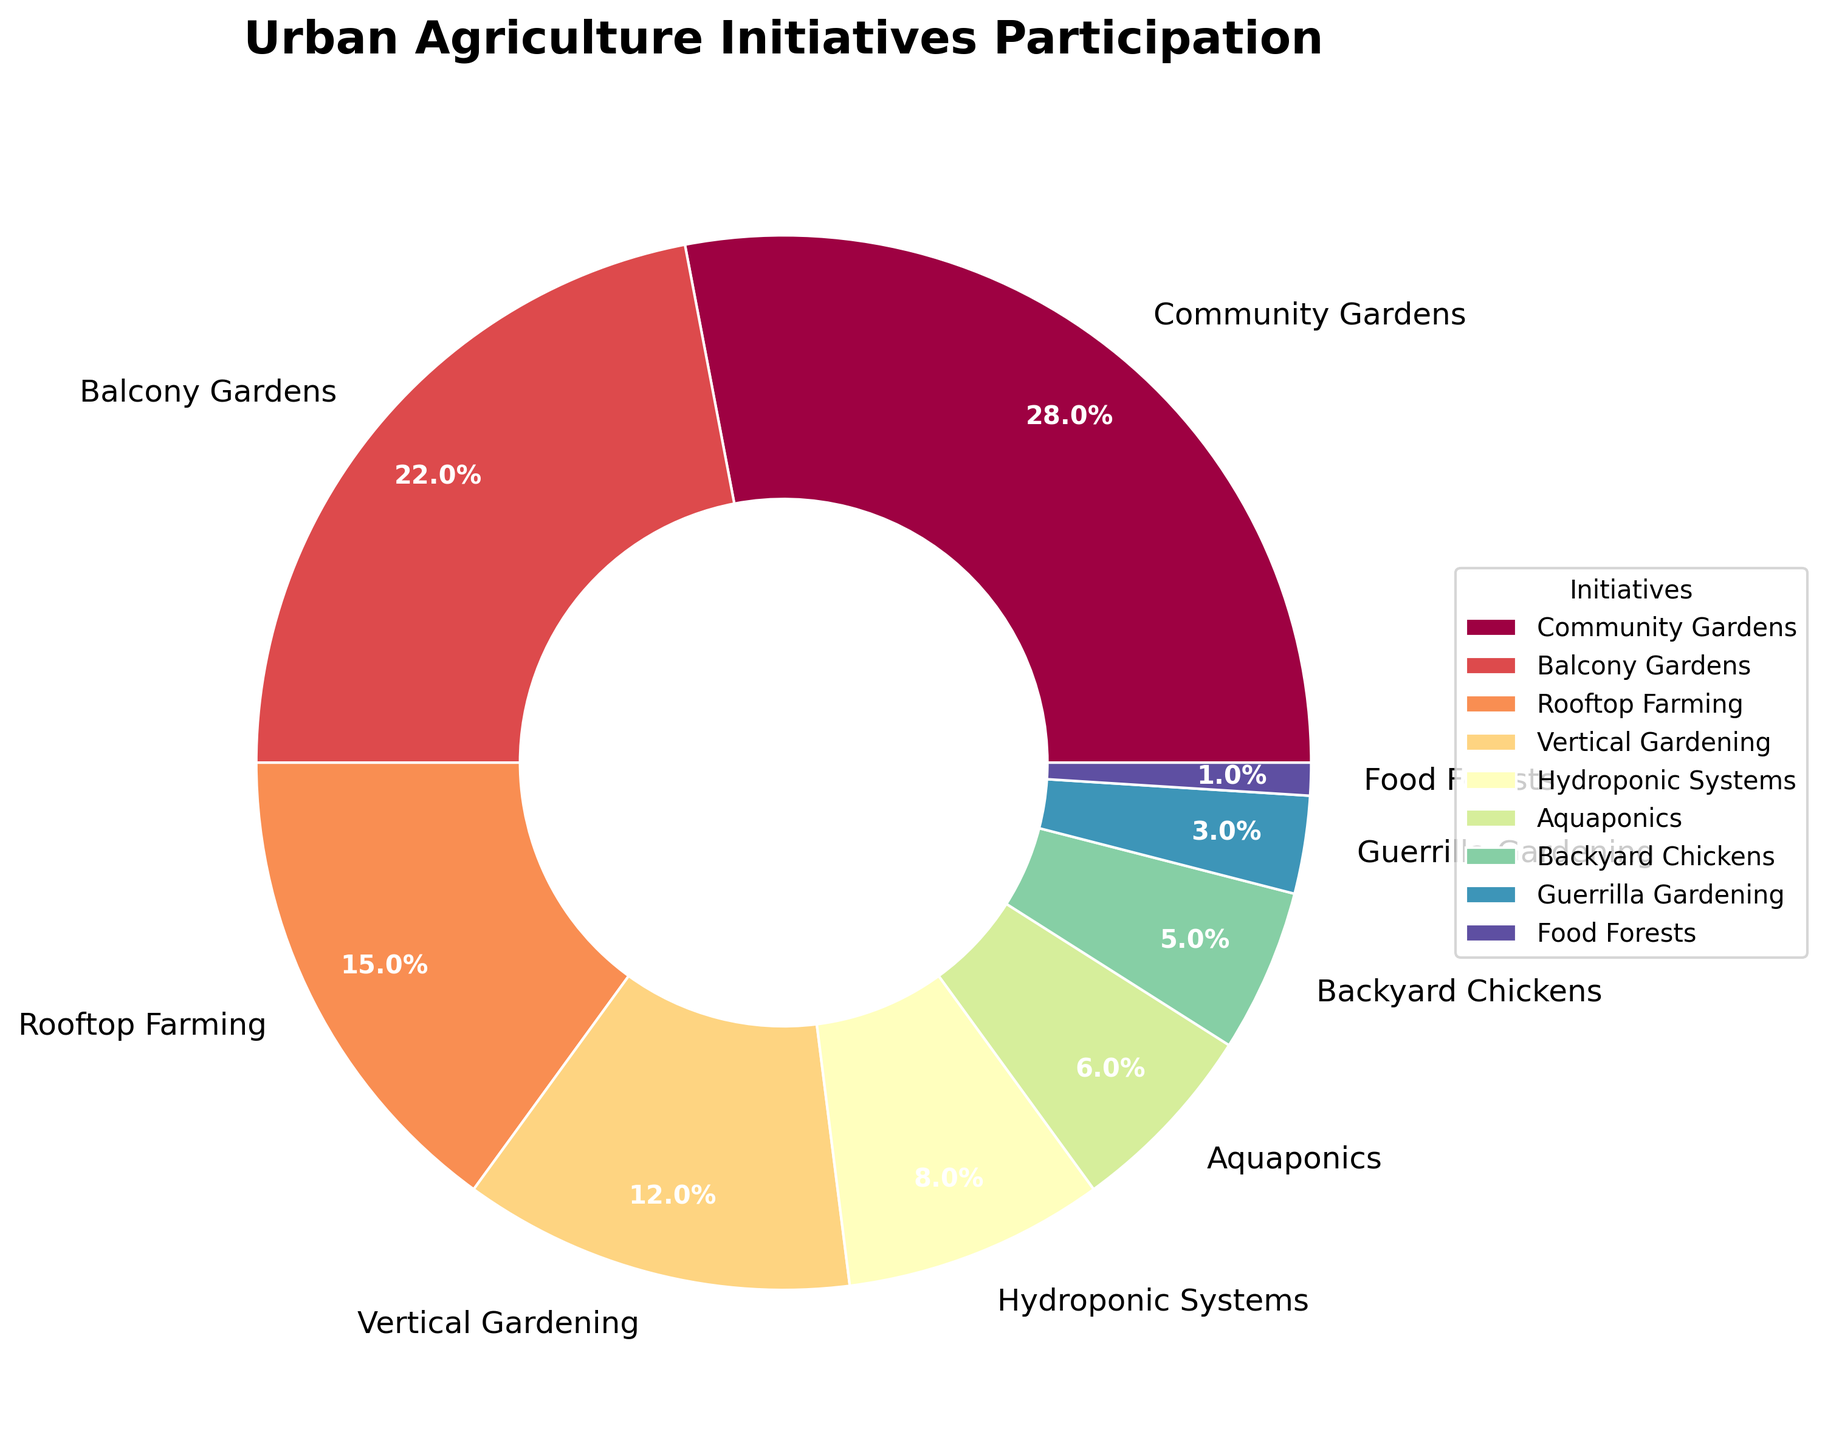What is the total percentage of households participating in Community Gardens and Balcony Gardens combined? To find the total percentage of households participating in Community Gardens and Balcony Gardens, simply add the percentage values for these two initiatives: 28% (Community Gardens) + 22% (Balcony Gardens) = 50%.
Answer: 50% What percentage of households participate in initiatives involving food production (Backyard Chickens and Food Forests) compared to hydroponic systems? Add the percentages of households involved in Backyard Chickens and Food Forests: 5% + 1% = 6%. Compare this sum to Hydroponic Systems: 6% (Backyard Chickens and Food Forests) vs. 8% (Hydroponic Systems).
Answer: 6% vs. 8% Which initiative has more participation: Rooftop Farming or Vertical Gardening? Compare the percentages of Rooftop Farming and Vertical Gardening. Rooftop Farming has 15% and Vertical Gardening has 12%. Therefore, Rooftop Farming has more participation.
Answer: Rooftop Farming What is the combined percentage of households involved in Hydroponic Systems, Aquaponics, and Guerrilla Gardening? Add the percentages of households involved in Hydroponic Systems (8%), Aquaponics (6%), and Guerrilla Gardening (3%): 8% + 6% + 3% = 17%.
Answer: 17% What is the smallest category and its corresponding percentage? Look at the pie chart to identify the smallest section. The smallest category is Food Forests with a percentage of 1%.
Answer: Food Forests, 1% How does the participation in Balcony Gardens compare to Rooftop Farming? Compare the percentages: Balcony Gardens has 22% and Rooftop Farming has 15%. Thus, Balcony Gardens has higher participation.
Answer: Balcony Gardens Which three initiatives have the largest participation and what are their combined percentages? Identify the three largest sections of the pie chart: Community Gardens (28%), Balcony Gardens (22%), and Rooftop Farming (15%). Add their percentages: 28% + 22% + 15% = 65%.
Answer: Community Gardens, Balcony Gardens, Rooftop Farming, 65% Is the participation in Vertical Gardening greater than the combined participation of Aquaponics and Guerrilla Gardening? Compare the percentages: Vertical Gardening has 12%, while the combined participation for Aquaponics (6%) and Guerrilla Gardening (3%) is 6% + 3% = 9%. Vertical Gardening has greater participation.
Answer: Yes, Vertical Gardening is greater What is the color distribution's significance in differentiating the initiatives? The pie chart uses a range of colors from a spectral colormap to visually distinguish between different initiatives. Each sector is a different color, making it easier to identify and compare the initiatives.
Answer: Different colors differentiate initiatives Does the least participated initiative Food Forests occupy a significant portion of the pie compared to the most participated initiative Community Gardens? Compare the visual sizes of the segments. Food Forests, with 1%, occupies a much smaller portion of the pie chart compared to Community Gardens, which occupies 28% of the pie chart.
Answer: No, Food Forests is significantly smaller 